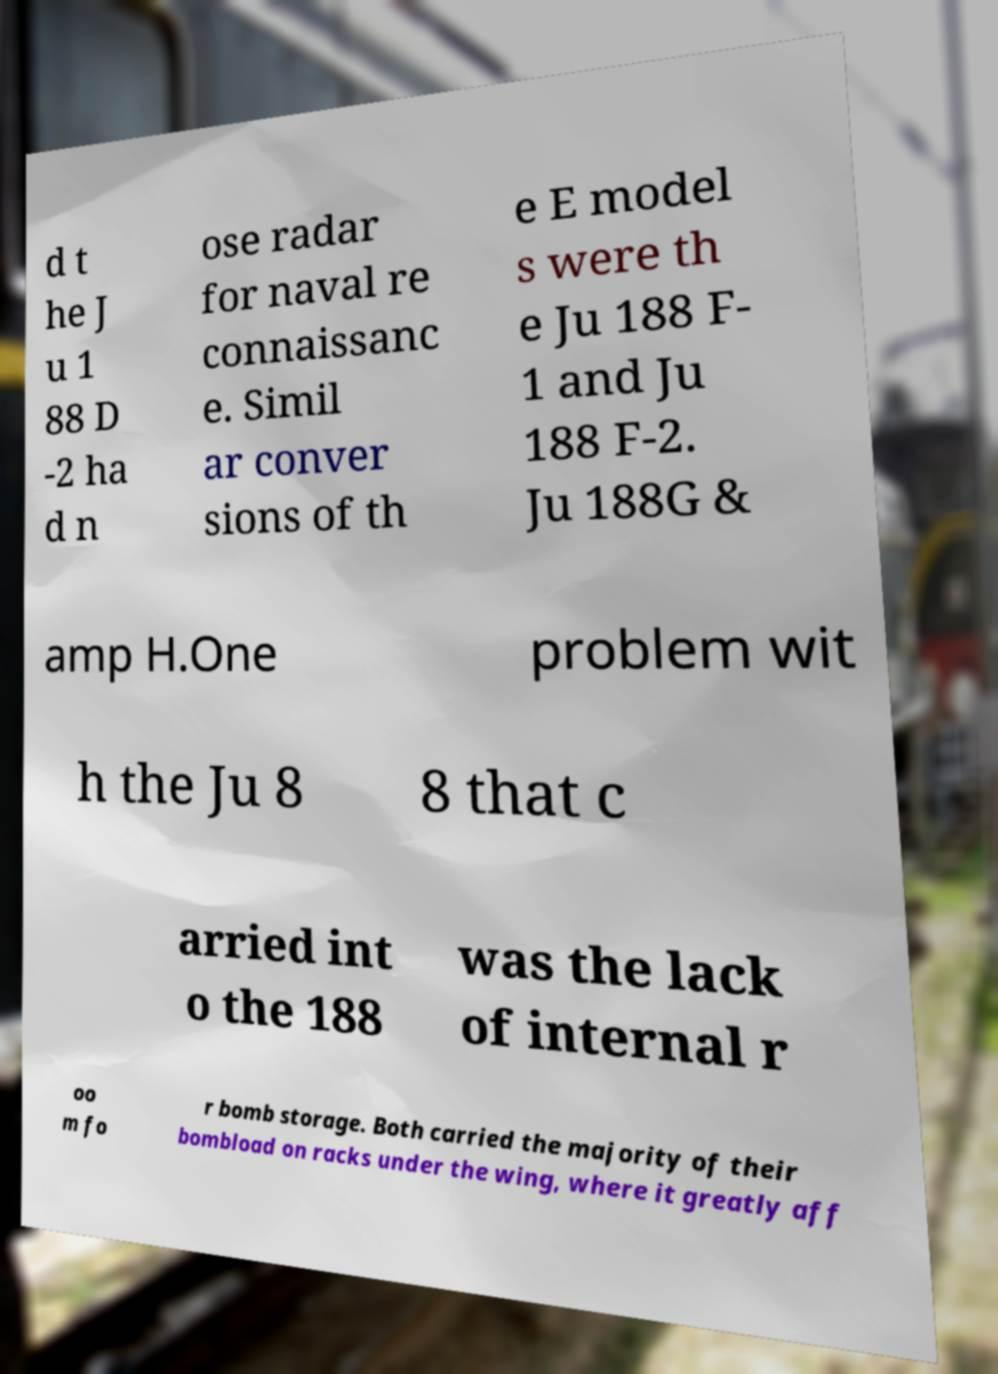Please identify and transcribe the text found in this image. d t he J u 1 88 D -2 ha d n ose radar for naval re connaissanc e. Simil ar conver sions of th e E model s were th e Ju 188 F- 1 and Ju 188 F-2. Ju 188G & amp H.One problem wit h the Ju 8 8 that c arried int o the 188 was the lack of internal r oo m fo r bomb storage. Both carried the majority of their bombload on racks under the wing, where it greatly aff 